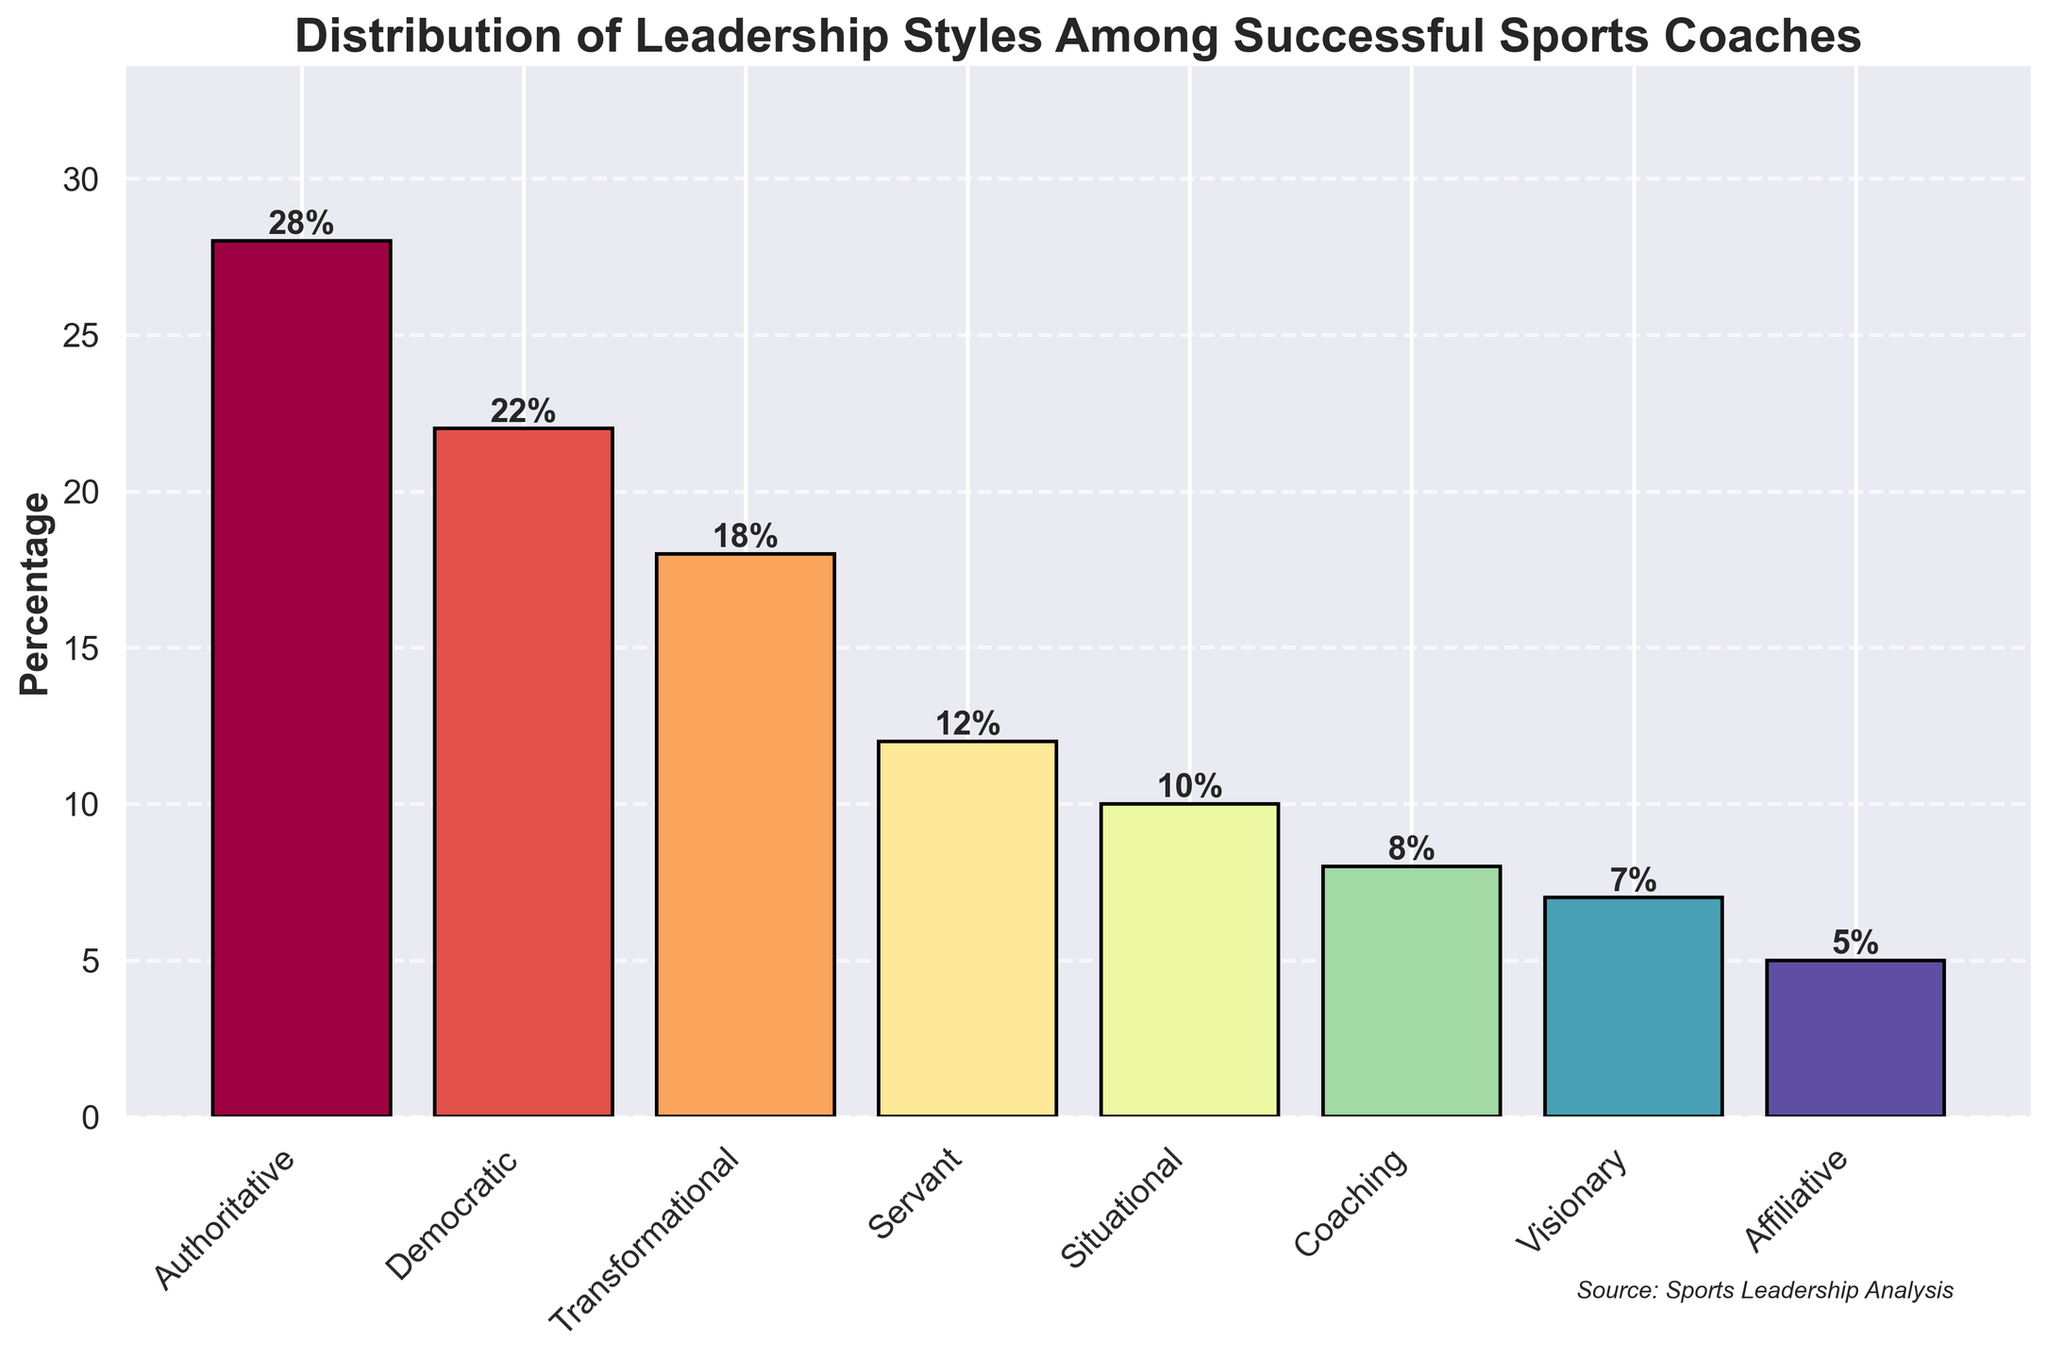Which leadership style is the most common among successful sports coaches? The highest bar represents the most common leadership style. In the chart, it is the Authoritative style.
Answer: Authoritative Which leadership style has the lowest percentage? The smallest bar in the chart indicates the lowest percentage. It is the Affiliative style.
Answer: Affiliative How much higher is the percentage of Authoritative leadership compared to Visionary leadership? The percentage of Authoritative leadership is 28%, and the Visionary is 7%. Subtract the percentage of Visionary from Authoritative: 28% - 7%.
Answer: 21% What is the combined percentage of Democratic and Transformational leadership styles? The Democratic leadership style is 22% and the Transformational style is 18%. Add these two percentages: 22% + 18%.
Answer: 40% By how much does the Democratic leadership style exceed the Coaching leadership style? The percentage of Democratic leadership is 22%, and the Coaching is 8%. Subtract the percentage of Coaching from Democratic: 22% - 8%.
Answer: 14% Which leadership style has a percentage closest to the average percentage of all listed styles? First, calculate the average: (28 + 22 + 18 + 12 + 10 + 8 + 7 + 5) / 8 = 13.75%. Then, compare each leadership style's percentage to 13.75%. The closest is the Situational leadership style with 10%.
Answer: Situational How do the combined percentages of the top three leadership styles compare to the other styles combined? Sum the top three styles: 28% (Authoritative) + 22% (Democratic) + 18% (Transformational) = 68%. Sum the remaining styles: 12% (Servant) + 10% (Situational) + 8% (Coaching) + 7% (Visionary) + 5% (Affiliative) = 42%. Compare 68% and 42%.
Answer: The top three styles have 26% more combined Which leadership style has the second lowest percentage and what is its value? The second smallest bar represents the second lowest percentage, which is the Visionary style with a percentage of 7%.
Answer: Visionary, 7% What is the sum of percentages of leadership styles that are above 20%? Identify the percentages above 20%: Authoritative (28%), Democratic (22%). Sum these: 28% + 22%.
Answer: 50% 